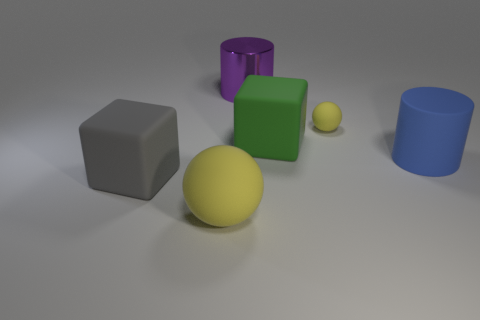What number of big matte spheres are on the right side of the object that is to the right of the rubber ball right of the shiny cylinder?
Give a very brief answer. 0. There is a object that is left of the yellow ball to the left of the purple thing; how big is it?
Provide a succinct answer. Large. The block that is made of the same material as the large green thing is what size?
Offer a very short reply. Large. What is the shape of the big thing that is behind the big sphere and in front of the big blue rubber thing?
Make the answer very short. Cube. Are there the same number of cylinders behind the tiny yellow matte object and gray blocks?
Make the answer very short. Yes. What number of things are large gray spheres or things that are in front of the purple metal thing?
Offer a very short reply. 5. Is there a large yellow object of the same shape as the tiny thing?
Your answer should be very brief. Yes. Is the number of small yellow things in front of the green rubber cube the same as the number of yellow spheres that are in front of the large yellow rubber thing?
Your answer should be very brief. Yes. How many green things are matte balls or big cubes?
Ensure brevity in your answer.  1. How many purple metallic blocks are the same size as the gray object?
Make the answer very short. 0. 